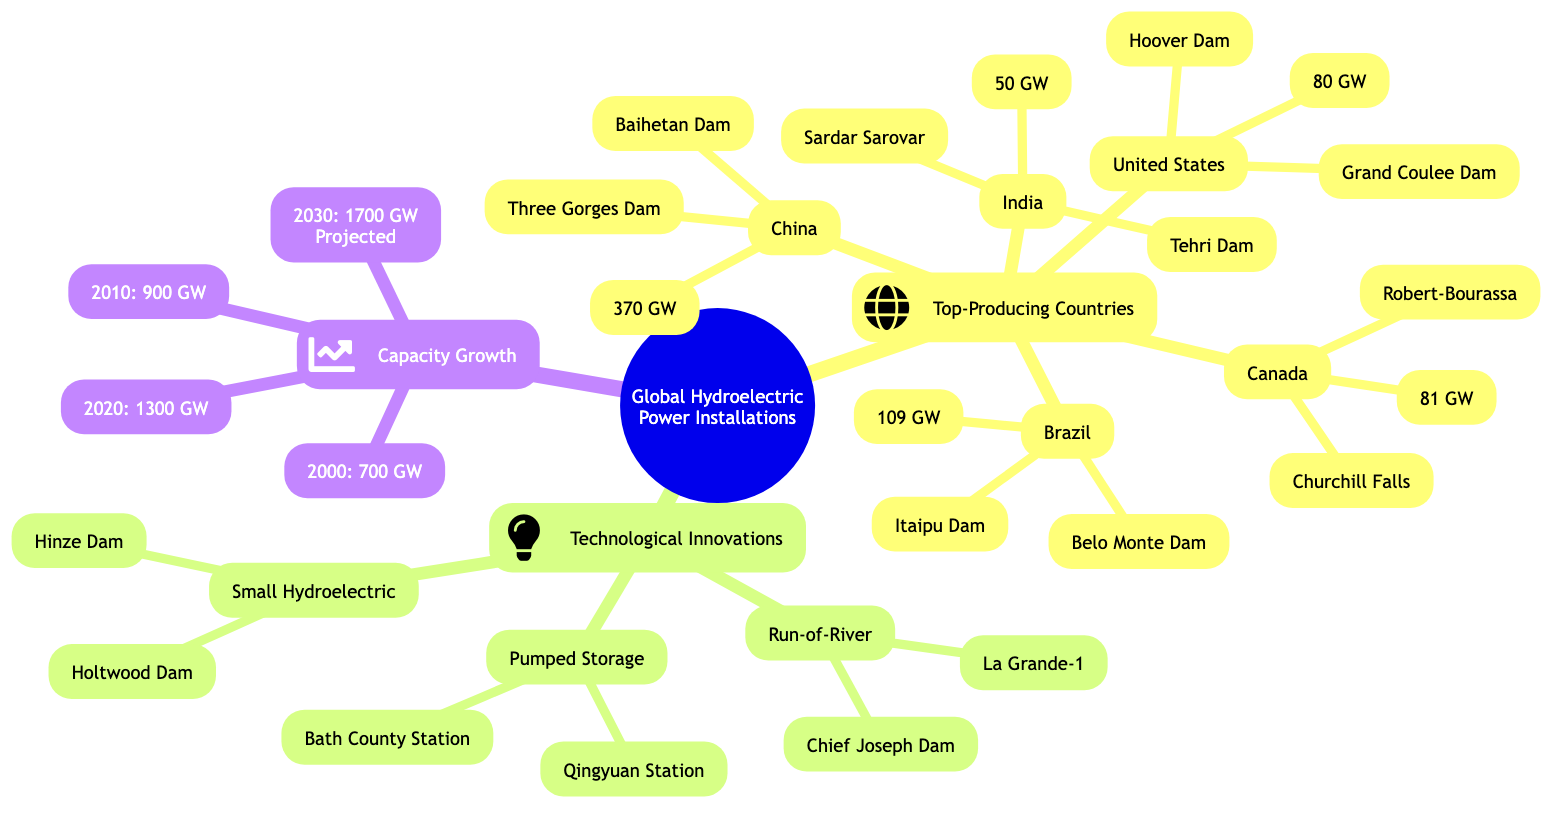What is the hydroelectric capacity of China? The diagram reveals that China's hydroelectric capacity is directly stated as 370 GW under its corresponding node.
Answer: 370 GW How many major dams are listed for Brazil? The diagram shows two major dams for Brazil: Itaipu Dam and Belo Monte Dam, indicating a total of two dams mentioned in that section.
Answer: 2 What is the projected hydroelectric capacity for 2030? By checking the diagram, the projected capacity for 2030 is specified clearly as 1700 GW, located in the section dedicated to capacity growth over the years.
Answer: 1700 GW Which country has the highest hydroelectric power capacity? The diagram indicates that China has the highest capacity, listed as 370 GW, which clearly exceeds the capacities of the other countries shown.
Answer: China List one major dam from India. The diagram outlines two major dams for India: Tehri Dam and Sardar Sarovar. The question only requires one, so either can be accepted.
Answer: Tehri Dam Which type of technological innovation is associated with the Bath County Pumped Storage Station? The Bath County Pumped Storage Station is categorized under the pumped storage section in the diagram, identifying the type of innovation linked to it.
Answer: Pumped Storage What is the capacity of the Itaipu Dam? The diagram does not explicitly state the capacity of the Itaipu Dam, but it is associated with Brazil, which has a total capacity of 109 GW. However, the capacity of the Itaipu Dam is known outside the diagram to be around 14 GW.
Answer: 14 GW Which country is associated with the Grand Coulee Dam? The diagram shows that the Grand Coulee Dam is linked to the United States, indicating this country as the association clearly under its section.
Answer: United States What is the total number of major dams mentioned in the diagram? To find this, we count the number of major dams listed for each country: China (2) + Brazil (2) + Canada (2) + United States (2) + India (2) = 10 dams total.
Answer: 10 